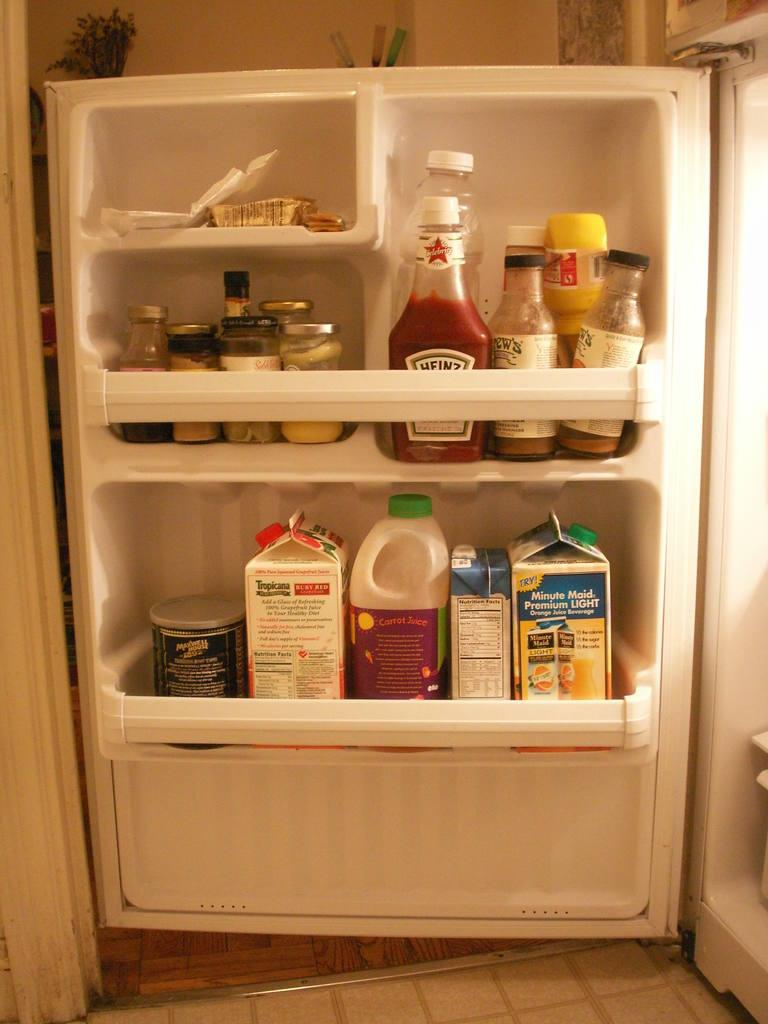<image>
Share a concise interpretation of the image provided. The ketchup in the fridge is made by Heinz. 